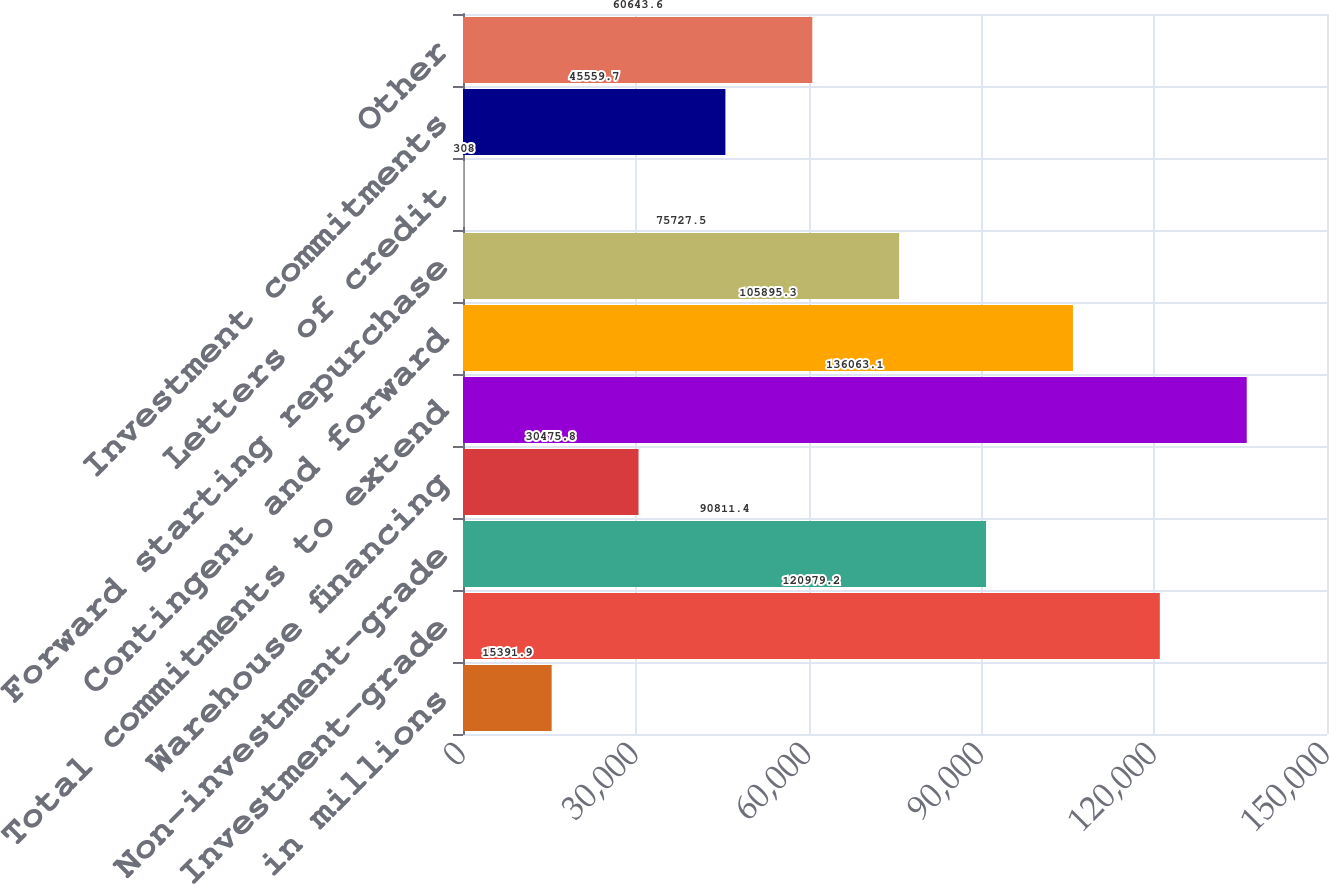<chart> <loc_0><loc_0><loc_500><loc_500><bar_chart><fcel>in millions<fcel>Investment-grade<fcel>Non-investment-grade<fcel>Warehouse financing<fcel>Total commitments to extend<fcel>Contingent and forward<fcel>Forward starting repurchase<fcel>Letters of credit<fcel>Investment commitments<fcel>Other<nl><fcel>15391.9<fcel>120979<fcel>90811.4<fcel>30475.8<fcel>136063<fcel>105895<fcel>75727.5<fcel>308<fcel>45559.7<fcel>60643.6<nl></chart> 